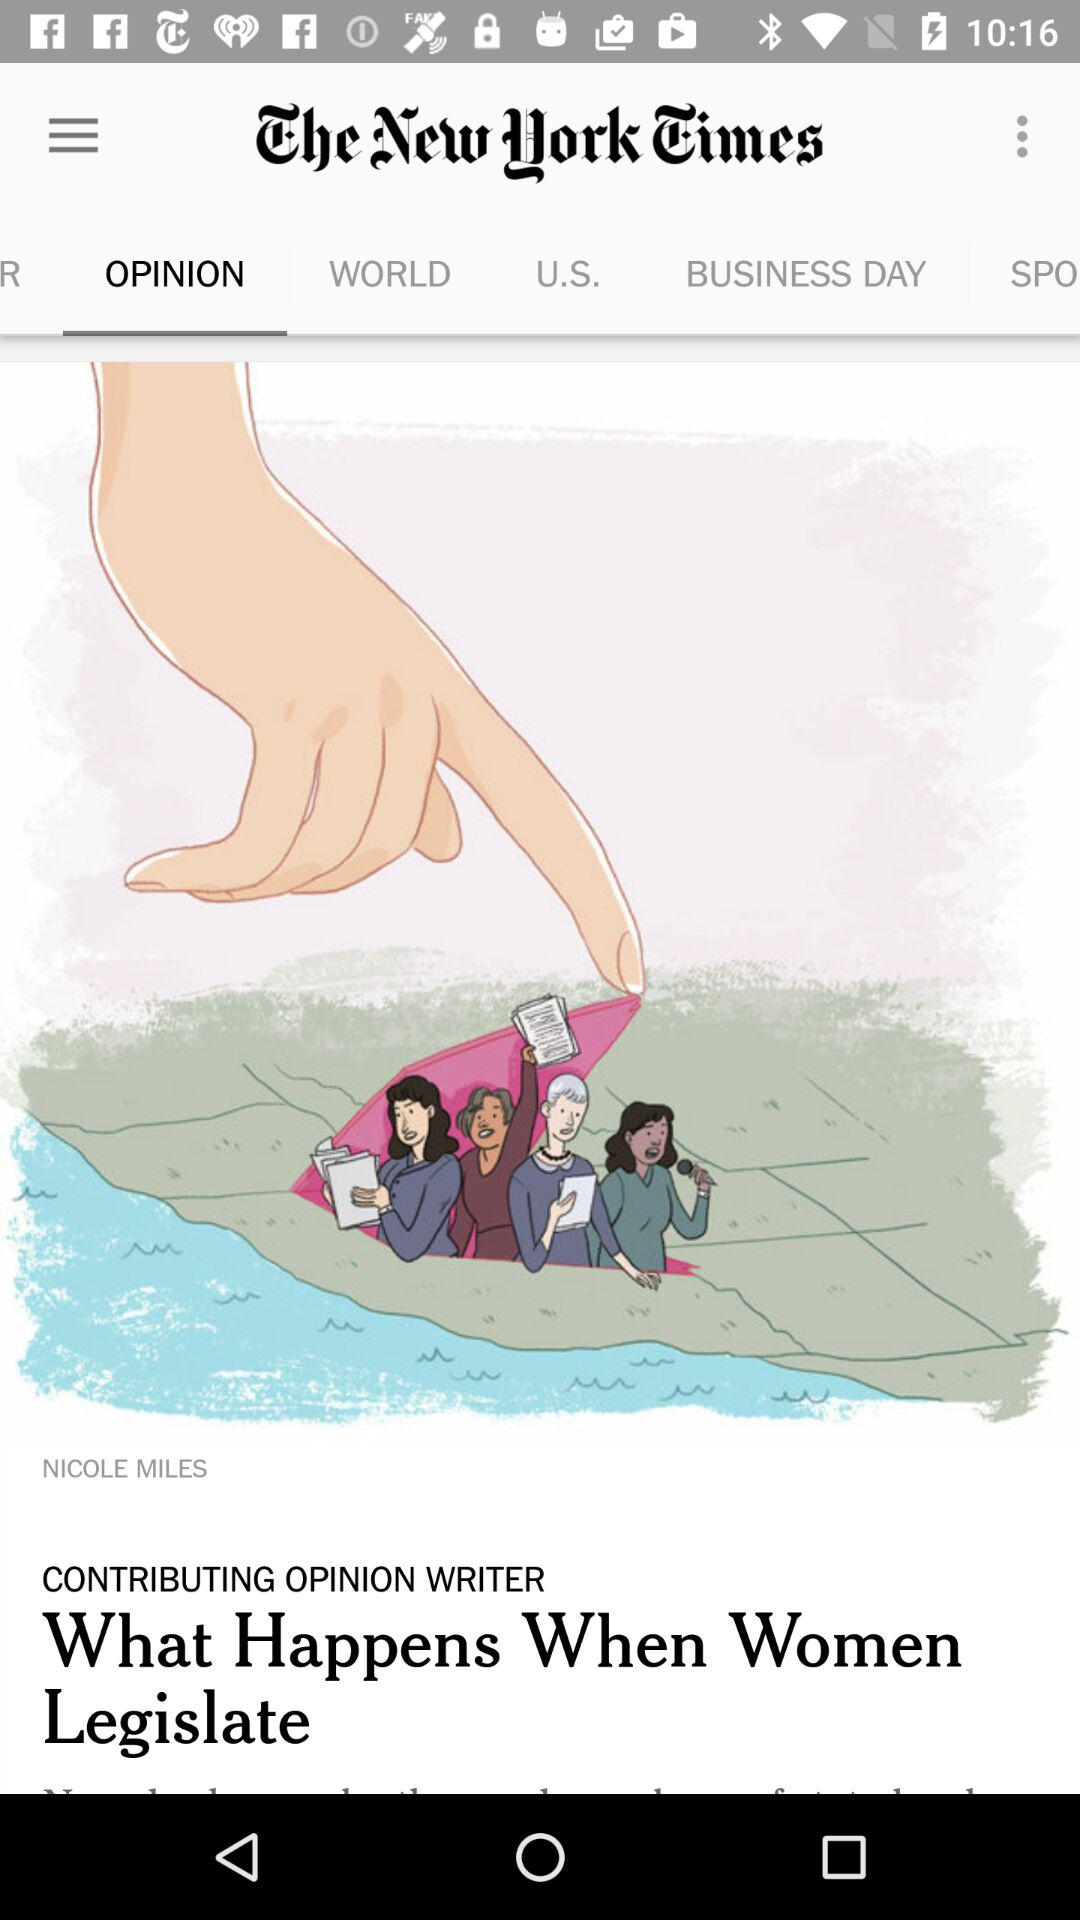Who is the writer? The writer is "Nicole Miles". 